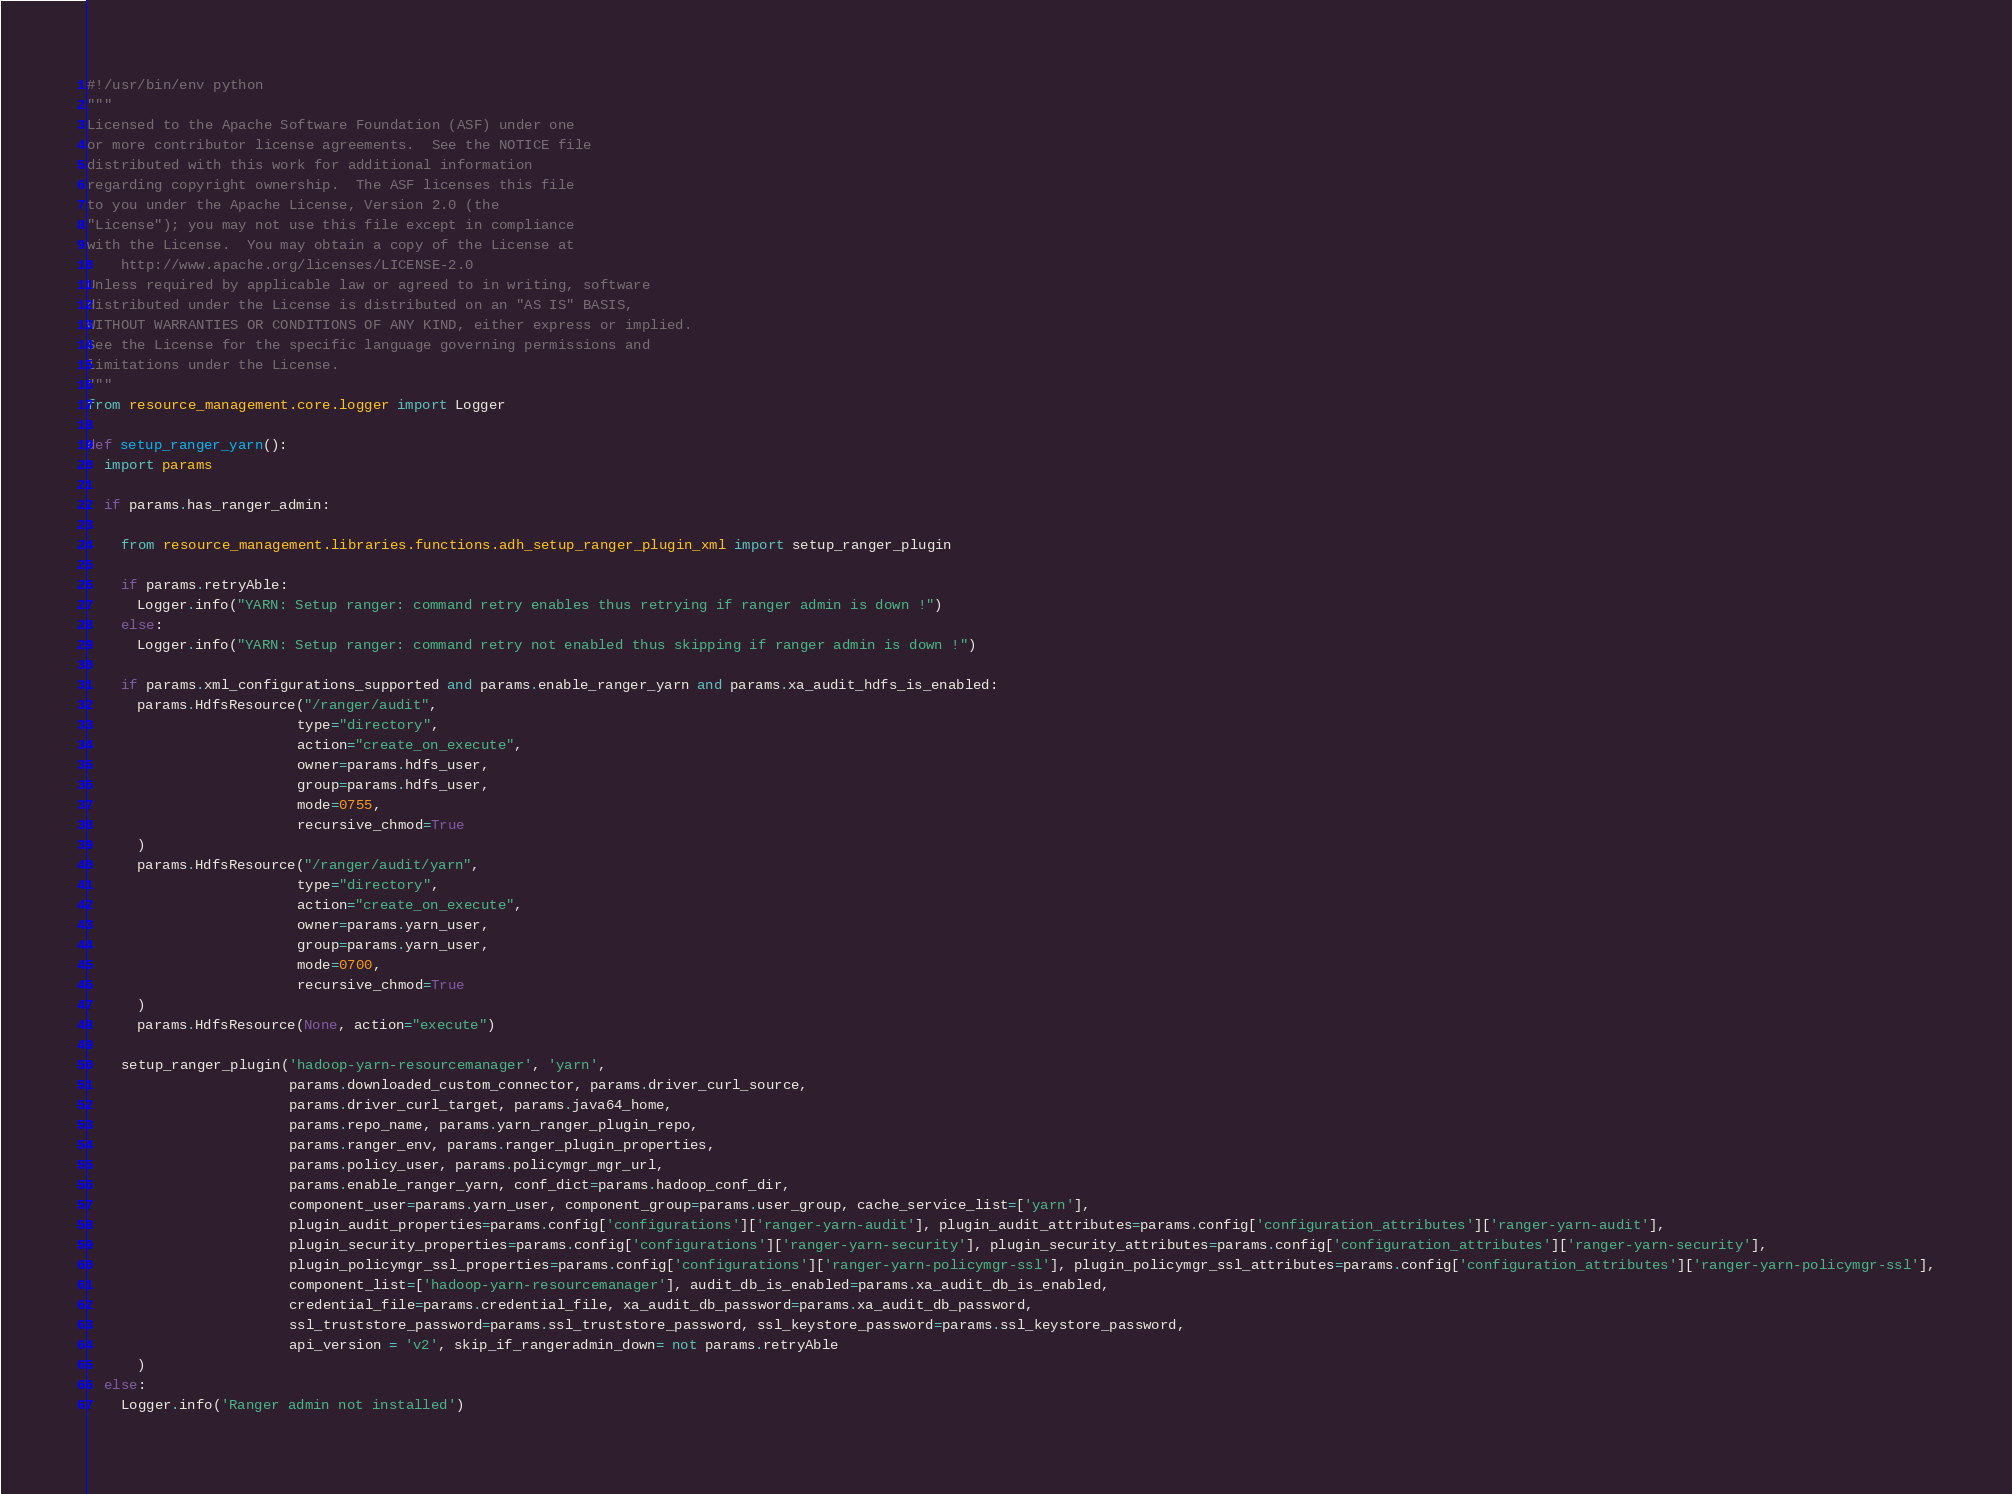Convert code to text. <code><loc_0><loc_0><loc_500><loc_500><_Python_>#!/usr/bin/env python
"""
Licensed to the Apache Software Foundation (ASF) under one
or more contributor license agreements.  See the NOTICE file
distributed with this work for additional information
regarding copyright ownership.  The ASF licenses this file
to you under the Apache License, Version 2.0 (the
"License"); you may not use this file except in compliance
with the License.  You may obtain a copy of the License at
    http://www.apache.org/licenses/LICENSE-2.0
Unless required by applicable law or agreed to in writing, software
distributed under the License is distributed on an "AS IS" BASIS,
WITHOUT WARRANTIES OR CONDITIONS OF ANY KIND, either express or implied.
See the License for the specific language governing permissions and
limitations under the License.
"""
from resource_management.core.logger import Logger

def setup_ranger_yarn():
  import params

  if params.has_ranger_admin:

    from resource_management.libraries.functions.adh_setup_ranger_plugin_xml import setup_ranger_plugin

    if params.retryAble:
      Logger.info("YARN: Setup ranger: command retry enables thus retrying if ranger admin is down !")
    else:
      Logger.info("YARN: Setup ranger: command retry not enabled thus skipping if ranger admin is down !")

    if params.xml_configurations_supported and params.enable_ranger_yarn and params.xa_audit_hdfs_is_enabled:
      params.HdfsResource("/ranger/audit",
                         type="directory",
                         action="create_on_execute",
                         owner=params.hdfs_user,
                         group=params.hdfs_user,
                         mode=0755,
                         recursive_chmod=True
      )
      params.HdfsResource("/ranger/audit/yarn",
                         type="directory",
                         action="create_on_execute",
                         owner=params.yarn_user,
                         group=params.yarn_user,
                         mode=0700,
                         recursive_chmod=True
      )
      params.HdfsResource(None, action="execute")

    setup_ranger_plugin('hadoop-yarn-resourcemanager', 'yarn', 
                        params.downloaded_custom_connector, params.driver_curl_source,
                        params.driver_curl_target, params.java64_home,
                        params.repo_name, params.yarn_ranger_plugin_repo,
                        params.ranger_env, params.ranger_plugin_properties,
                        params.policy_user, params.policymgr_mgr_url,
                        params.enable_ranger_yarn, conf_dict=params.hadoop_conf_dir,
                        component_user=params.yarn_user, component_group=params.user_group, cache_service_list=['yarn'],
                        plugin_audit_properties=params.config['configurations']['ranger-yarn-audit'], plugin_audit_attributes=params.config['configuration_attributes']['ranger-yarn-audit'],
                        plugin_security_properties=params.config['configurations']['ranger-yarn-security'], plugin_security_attributes=params.config['configuration_attributes']['ranger-yarn-security'],
                        plugin_policymgr_ssl_properties=params.config['configurations']['ranger-yarn-policymgr-ssl'], plugin_policymgr_ssl_attributes=params.config['configuration_attributes']['ranger-yarn-policymgr-ssl'],
                        component_list=['hadoop-yarn-resourcemanager'], audit_db_is_enabled=params.xa_audit_db_is_enabled,
                        credential_file=params.credential_file, xa_audit_db_password=params.xa_audit_db_password, 
                        ssl_truststore_password=params.ssl_truststore_password, ssl_keystore_password=params.ssl_keystore_password,
                        api_version = 'v2', skip_if_rangeradmin_down= not params.retryAble
      )                 
  else:
    Logger.info('Ranger admin not installed')</code> 